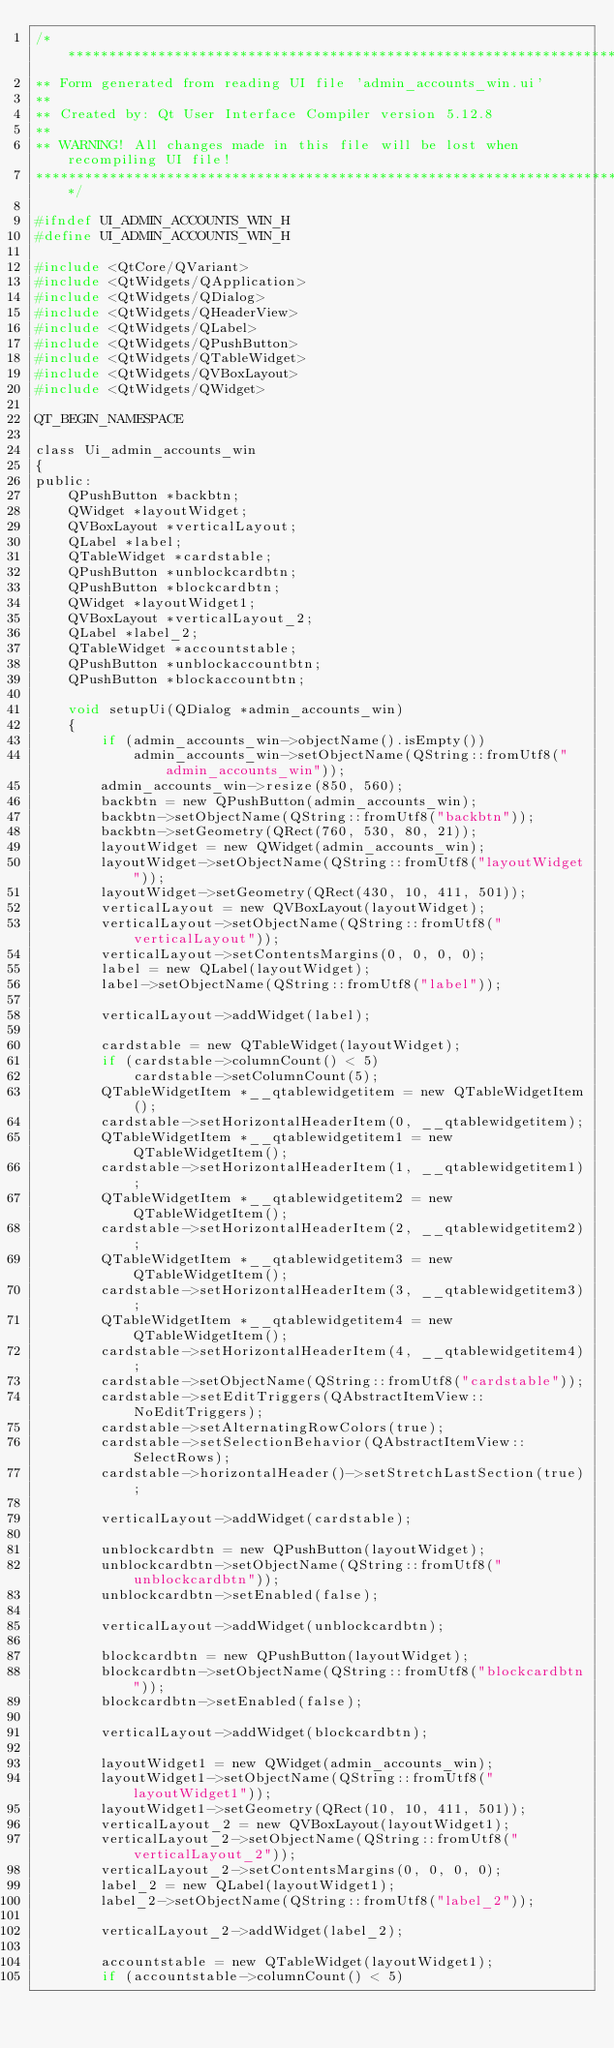Convert code to text. <code><loc_0><loc_0><loc_500><loc_500><_C_>/********************************************************************************
** Form generated from reading UI file 'admin_accounts_win.ui'
**
** Created by: Qt User Interface Compiler version 5.12.8
**
** WARNING! All changes made in this file will be lost when recompiling UI file!
********************************************************************************/

#ifndef UI_ADMIN_ACCOUNTS_WIN_H
#define UI_ADMIN_ACCOUNTS_WIN_H

#include <QtCore/QVariant>
#include <QtWidgets/QApplication>
#include <QtWidgets/QDialog>
#include <QtWidgets/QHeaderView>
#include <QtWidgets/QLabel>
#include <QtWidgets/QPushButton>
#include <QtWidgets/QTableWidget>
#include <QtWidgets/QVBoxLayout>
#include <QtWidgets/QWidget>

QT_BEGIN_NAMESPACE

class Ui_admin_accounts_win
{
public:
    QPushButton *backbtn;
    QWidget *layoutWidget;
    QVBoxLayout *verticalLayout;
    QLabel *label;
    QTableWidget *cardstable;
    QPushButton *unblockcardbtn;
    QPushButton *blockcardbtn;
    QWidget *layoutWidget1;
    QVBoxLayout *verticalLayout_2;
    QLabel *label_2;
    QTableWidget *accountstable;
    QPushButton *unblockaccountbtn;
    QPushButton *blockaccountbtn;

    void setupUi(QDialog *admin_accounts_win)
    {
        if (admin_accounts_win->objectName().isEmpty())
            admin_accounts_win->setObjectName(QString::fromUtf8("admin_accounts_win"));
        admin_accounts_win->resize(850, 560);
        backbtn = new QPushButton(admin_accounts_win);
        backbtn->setObjectName(QString::fromUtf8("backbtn"));
        backbtn->setGeometry(QRect(760, 530, 80, 21));
        layoutWidget = new QWidget(admin_accounts_win);
        layoutWidget->setObjectName(QString::fromUtf8("layoutWidget"));
        layoutWidget->setGeometry(QRect(430, 10, 411, 501));
        verticalLayout = new QVBoxLayout(layoutWidget);
        verticalLayout->setObjectName(QString::fromUtf8("verticalLayout"));
        verticalLayout->setContentsMargins(0, 0, 0, 0);
        label = new QLabel(layoutWidget);
        label->setObjectName(QString::fromUtf8("label"));

        verticalLayout->addWidget(label);

        cardstable = new QTableWidget(layoutWidget);
        if (cardstable->columnCount() < 5)
            cardstable->setColumnCount(5);
        QTableWidgetItem *__qtablewidgetitem = new QTableWidgetItem();
        cardstable->setHorizontalHeaderItem(0, __qtablewidgetitem);
        QTableWidgetItem *__qtablewidgetitem1 = new QTableWidgetItem();
        cardstable->setHorizontalHeaderItem(1, __qtablewidgetitem1);
        QTableWidgetItem *__qtablewidgetitem2 = new QTableWidgetItem();
        cardstable->setHorizontalHeaderItem(2, __qtablewidgetitem2);
        QTableWidgetItem *__qtablewidgetitem3 = new QTableWidgetItem();
        cardstable->setHorizontalHeaderItem(3, __qtablewidgetitem3);
        QTableWidgetItem *__qtablewidgetitem4 = new QTableWidgetItem();
        cardstable->setHorizontalHeaderItem(4, __qtablewidgetitem4);
        cardstable->setObjectName(QString::fromUtf8("cardstable"));
        cardstable->setEditTriggers(QAbstractItemView::NoEditTriggers);
        cardstable->setAlternatingRowColors(true);
        cardstable->setSelectionBehavior(QAbstractItemView::SelectRows);
        cardstable->horizontalHeader()->setStretchLastSection(true);

        verticalLayout->addWidget(cardstable);

        unblockcardbtn = new QPushButton(layoutWidget);
        unblockcardbtn->setObjectName(QString::fromUtf8("unblockcardbtn"));
        unblockcardbtn->setEnabled(false);

        verticalLayout->addWidget(unblockcardbtn);

        blockcardbtn = new QPushButton(layoutWidget);
        blockcardbtn->setObjectName(QString::fromUtf8("blockcardbtn"));
        blockcardbtn->setEnabled(false);

        verticalLayout->addWidget(blockcardbtn);

        layoutWidget1 = new QWidget(admin_accounts_win);
        layoutWidget1->setObjectName(QString::fromUtf8("layoutWidget1"));
        layoutWidget1->setGeometry(QRect(10, 10, 411, 501));
        verticalLayout_2 = new QVBoxLayout(layoutWidget1);
        verticalLayout_2->setObjectName(QString::fromUtf8("verticalLayout_2"));
        verticalLayout_2->setContentsMargins(0, 0, 0, 0);
        label_2 = new QLabel(layoutWidget1);
        label_2->setObjectName(QString::fromUtf8("label_2"));

        verticalLayout_2->addWidget(label_2);

        accountstable = new QTableWidget(layoutWidget1);
        if (accountstable->columnCount() < 5)</code> 